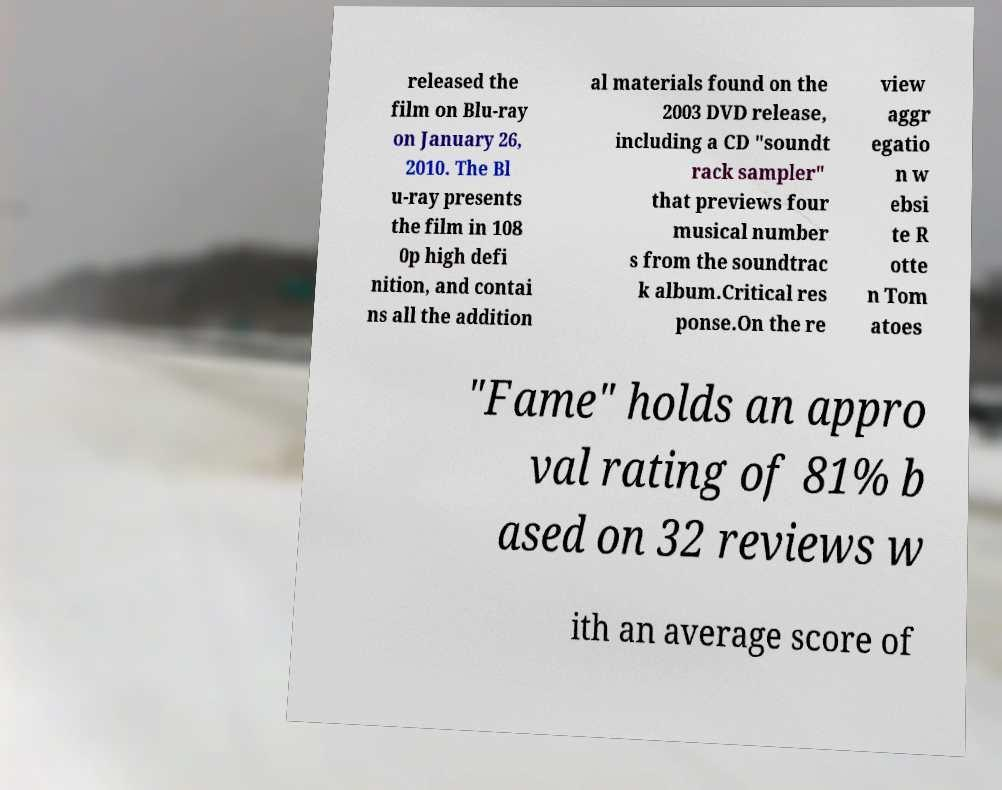There's text embedded in this image that I need extracted. Can you transcribe it verbatim? released the film on Blu-ray on January 26, 2010. The Bl u-ray presents the film in 108 0p high defi nition, and contai ns all the addition al materials found on the 2003 DVD release, including a CD "soundt rack sampler" that previews four musical number s from the soundtrac k album.Critical res ponse.On the re view aggr egatio n w ebsi te R otte n Tom atoes "Fame" holds an appro val rating of 81% b ased on 32 reviews w ith an average score of 